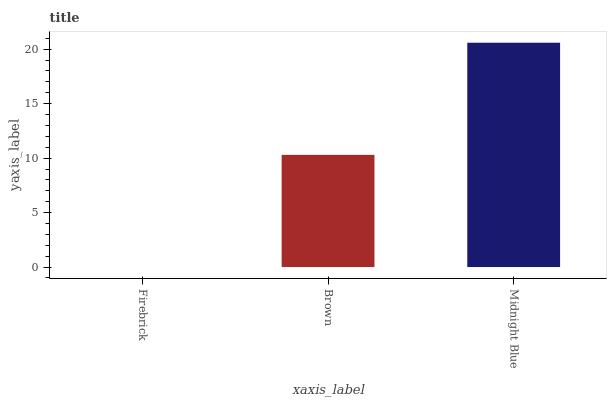Is Brown the minimum?
Answer yes or no. No. Is Brown the maximum?
Answer yes or no. No. Is Brown greater than Firebrick?
Answer yes or no. Yes. Is Firebrick less than Brown?
Answer yes or no. Yes. Is Firebrick greater than Brown?
Answer yes or no. No. Is Brown less than Firebrick?
Answer yes or no. No. Is Brown the high median?
Answer yes or no. Yes. Is Brown the low median?
Answer yes or no. Yes. Is Midnight Blue the high median?
Answer yes or no. No. Is Midnight Blue the low median?
Answer yes or no. No. 